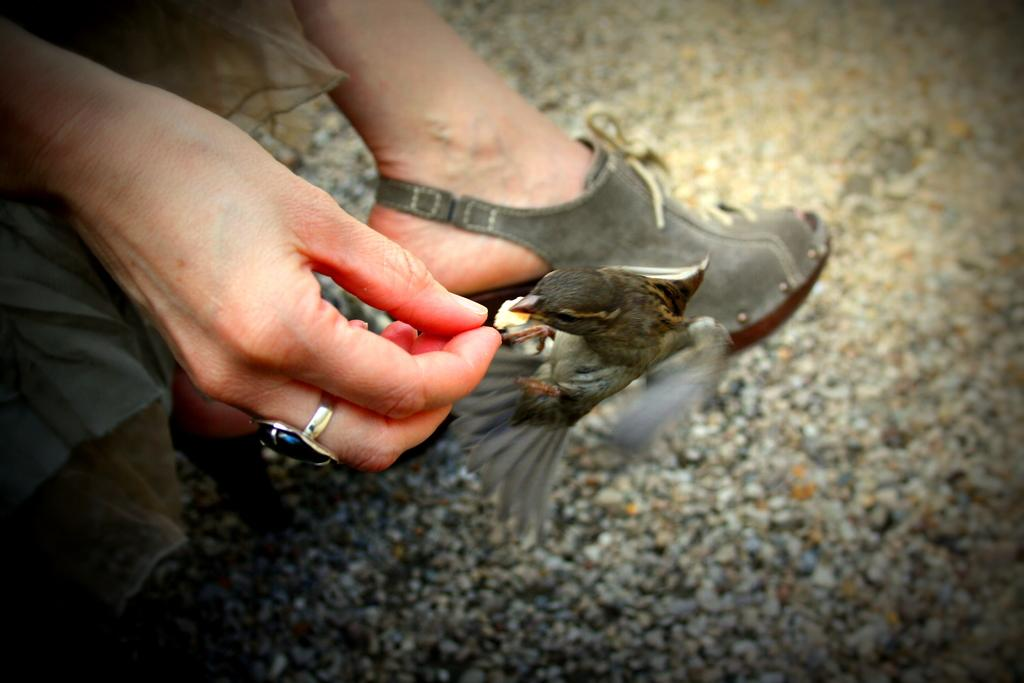What can be seen on the person's hand in the image? There is a person's hand with a ring in the image. What is in front of the hand? There is a bird in front of the hand. What is visible behind the bird? There is a leg with footwear behind the bird. What is on the ground in the image? There are stones on the ground in the image. Can you tell me how the bird is swimming in the image? There is no swimming depicted in the image; the bird is standing on the ground in front of the hand. What type of ray is visible in the image? There is no ray present in the image. 